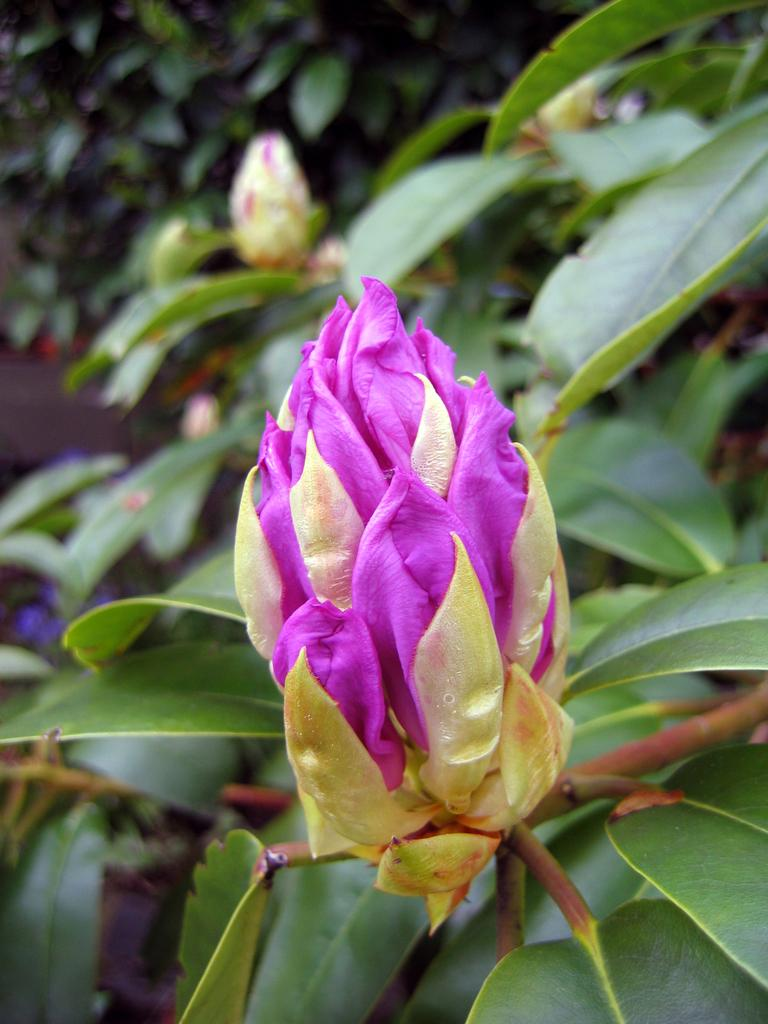What is the main subject in the center of the image? There are flowers in the center of the image. What color are the leaves associated with the flowers? There are green leaves in the image. Can you describe any other objects present in the image? There are other objects present in the image, but their specific details are not mentioned in the provided facts. How does the grip of the wine bottle affect the taste in the image? There is no wine bottle or mention of taste in the image; it features flowers and green leaves. 